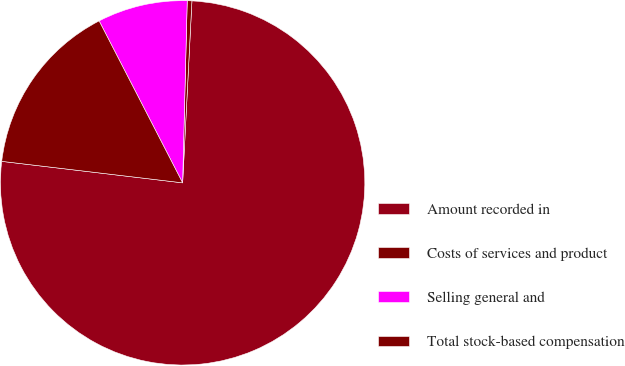Convert chart. <chart><loc_0><loc_0><loc_500><loc_500><pie_chart><fcel>Amount recorded in<fcel>Costs of services and product<fcel>Selling general and<fcel>Total stock-based compensation<nl><fcel>76.07%<fcel>0.41%<fcel>7.98%<fcel>15.54%<nl></chart> 